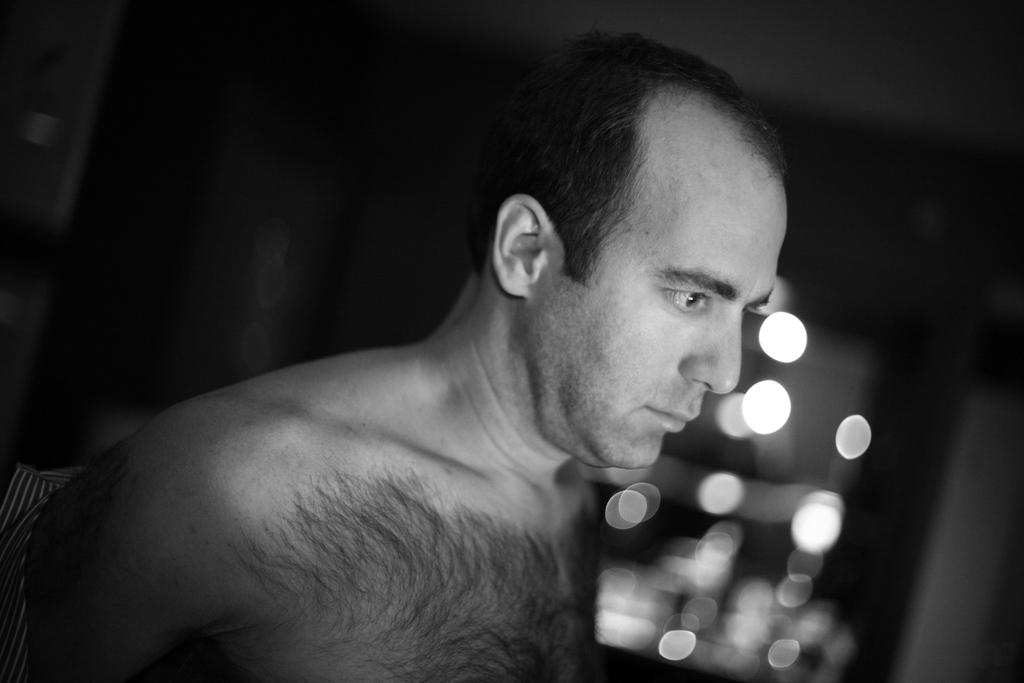What is the main subject of the image? There is a man standing in the image. Can you describe the man's attire in the image? The man is not wearing clothes in the image. What can be seen in the background of the image? There are lights visible in the background of the image. What type of army vehicles can be seen in the image? There are no army vehicles present in the image; it features a man standing without clothes and lights in the background. What town is depicted in the image? The image does not depict a town; it only shows a man standing without clothes and lights in the background. 